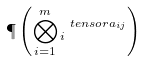Convert formula to latex. <formula><loc_0><loc_0><loc_500><loc_500>\P \left ( \bigotimes _ { i = 1 } ^ { m } \L _ { i } ^ { \ t e n s o r a _ { i j } } \right )</formula> 